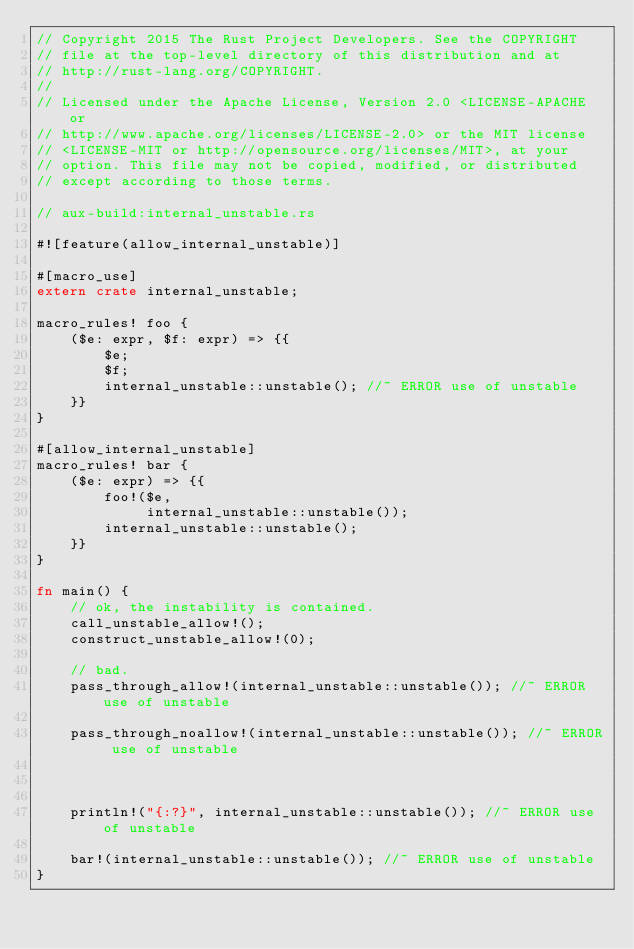Convert code to text. <code><loc_0><loc_0><loc_500><loc_500><_Rust_>// Copyright 2015 The Rust Project Developers. See the COPYRIGHT
// file at the top-level directory of this distribution and at
// http://rust-lang.org/COPYRIGHT.
//
// Licensed under the Apache License, Version 2.0 <LICENSE-APACHE or
// http://www.apache.org/licenses/LICENSE-2.0> or the MIT license
// <LICENSE-MIT or http://opensource.org/licenses/MIT>, at your
// option. This file may not be copied, modified, or distributed
// except according to those terms.

// aux-build:internal_unstable.rs

#![feature(allow_internal_unstable)]

#[macro_use]
extern crate internal_unstable;

macro_rules! foo {
    ($e: expr, $f: expr) => {{
        $e;
        $f;
        internal_unstable::unstable(); //~ ERROR use of unstable
    }}
}

#[allow_internal_unstable]
macro_rules! bar {
    ($e: expr) => {{
        foo!($e,
             internal_unstable::unstable());
        internal_unstable::unstable();
    }}
}

fn main() {
    // ok, the instability is contained.
    call_unstable_allow!();
    construct_unstable_allow!(0);

    // bad.
    pass_through_allow!(internal_unstable::unstable()); //~ ERROR use of unstable

    pass_through_noallow!(internal_unstable::unstable()); //~ ERROR use of unstable



    println!("{:?}", internal_unstable::unstable()); //~ ERROR use of unstable

    bar!(internal_unstable::unstable()); //~ ERROR use of unstable
}
</code> 